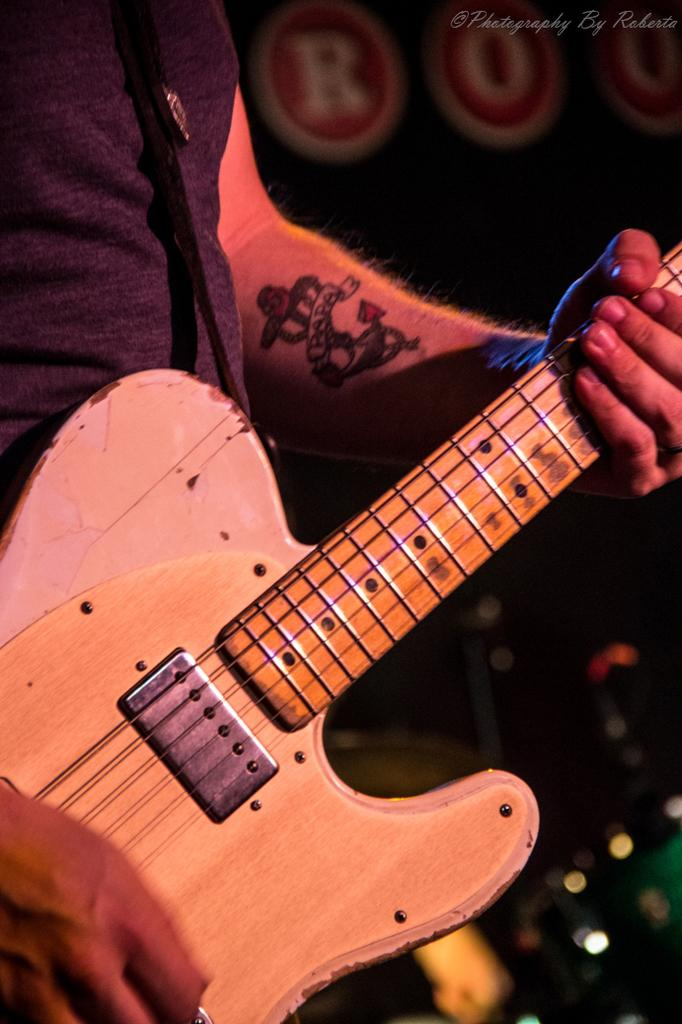What is the person in the image doing? The person is playing the guitar. What instrument is the person holding in the image? The person is holding a guitar. Can you describe any visible features on the person's body? The person has a tattoo on their hand. What type of government is depicted in the image? There is no depiction of a government in the image; it features a person playing a guitar. Can you describe the stranger in the image? There is no stranger present in the image; it features a person playing a guitar. 